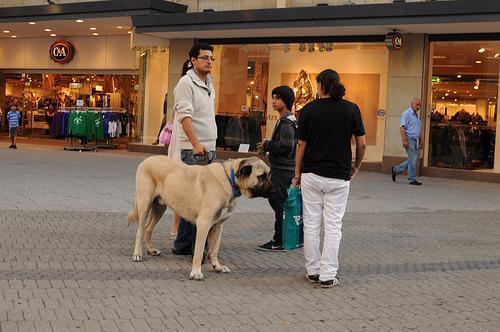How many people are holding the dog?
Give a very brief answer. 1. How many people are wearing white pants?
Give a very brief answer. 1. 